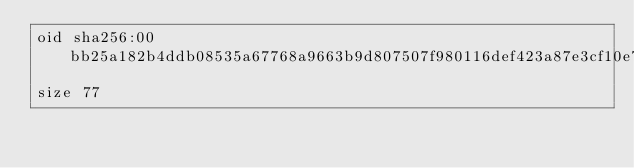Convert code to text. <code><loc_0><loc_0><loc_500><loc_500><_YAML_>oid sha256:00bb25a182b4ddb08535a67768a9663b9d807507f980116def423a87e3cf10e7
size 77
</code> 